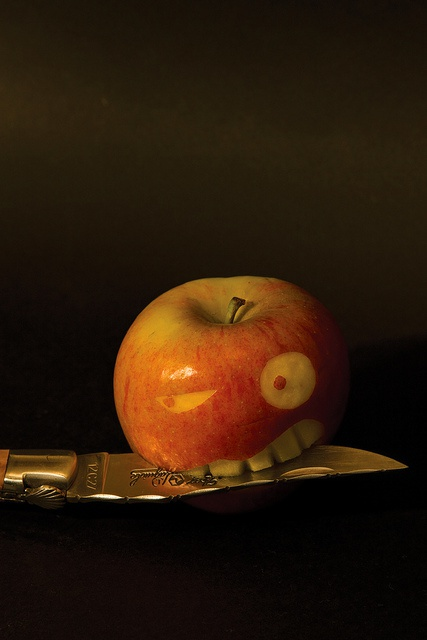Describe the objects in this image and their specific colors. I can see apple in black, brown, maroon, and red tones and knife in black, maroon, and brown tones in this image. 